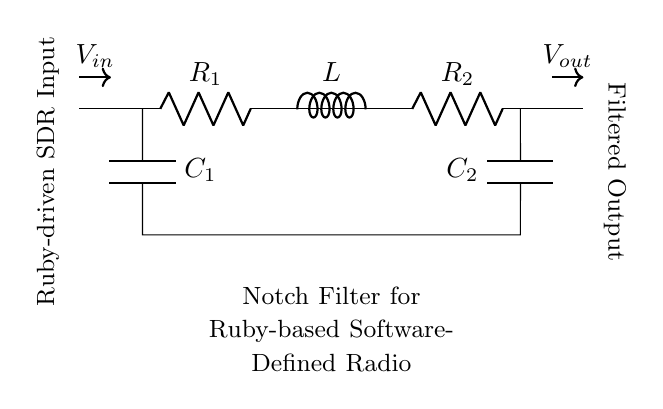What type of filter is represented in the diagram? The diagram illustrates a notch filter, which is designed to eliminate specific frequency components from a signal. This is indicated by its name and the configuration of components, particularly the resistors, capacitors, and inductor arranged specifically to perform this function.
Answer: Notch filter How many resistors are in the circuit? The circuit diagram shows two resistors, labeled R1 and R2, which are connected in series. Their indication on the circuit with the labels confirms they are both present and named accordingly.
Answer: Two What is the configuration of the capacitors in the circuit? The capacitors C1 and C2 are arranged in parallel with respect to the circuit, as they are positioned to connect across the same two nodes. This parallel connection contributes to the notch filter behavior by allowing certain frequencies to be shunted.
Answer: Parallel What is the position of the inductor in the circuit? The inductor labeled L is located between the two resistors R1 and R2, indicating its role in the filtering process. Its placement in series with the resistors is crucial for defining the frequency characteristics of the notch filter.
Answer: Between R1 and R2 What is the purpose of the notch filter in this context? The notch filter is intended to reduce or eliminate unwanted frequencies from the input signal of a Ruby-driven software-defined radio system. This purpose is derived from the design of the circuit and the context provided in the diagram description.
Answer: Eliminate specific frequencies What is the input labeled as in the schematic? The input of the circuit is labeled as V_in, which signifies the voltage input to the notch filter where the undesired frequencies are applied. This label provides clarity on the signal entering the filter.
Answer: V_in 